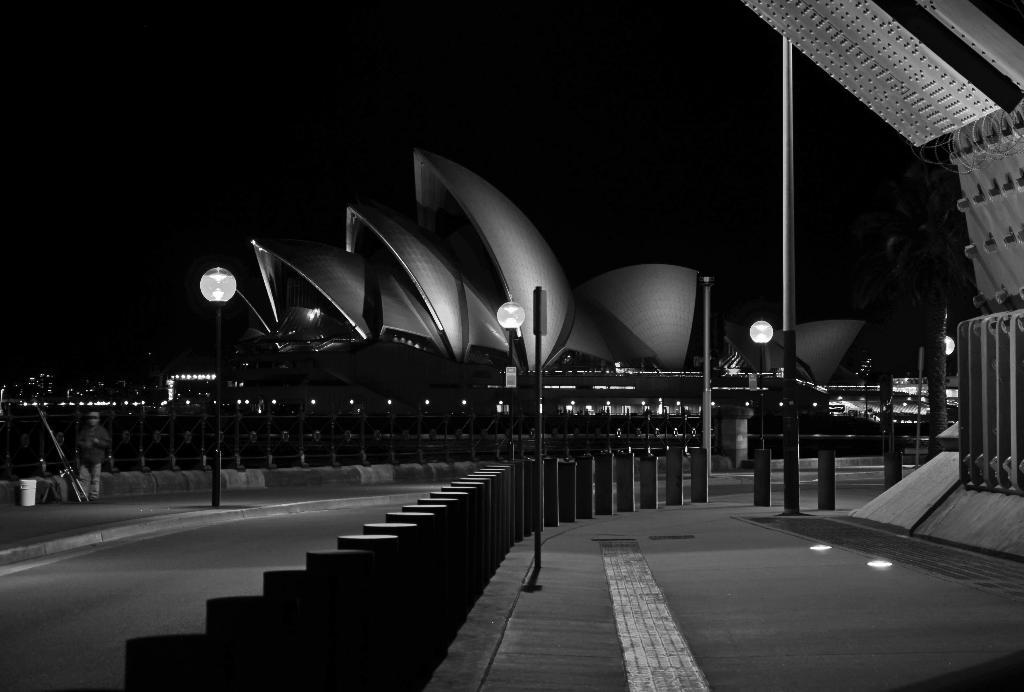What is located in the center of the image? There are poles in the center of the image. What can be seen in the background of the image? There are buildings in the background of the image. Is there anyone present in the image? Yes, there is a person in the image. What type of whip is the person using to control the territory in the image? There is no whip or territory present in the image; it features poles and a person. How is the thread being used by the person in the image? There is no thread present in the image; it features poles and a person. 